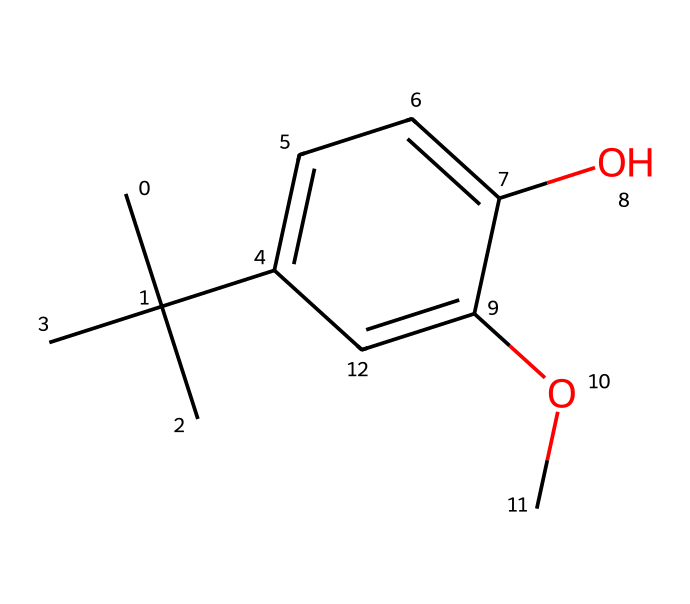What is the molecular formula of butylated hydroxyanisole? The SMILES representation can be analyzed to count the number of each type of atom present. In CC(C)(C), there are 4 carbons from the butyl group. The rest of the structure contains another 6 carbons from the aromatic ring. Including the attached functional groups, we see 10 carbons (C), 12 hydrogens (H), and 3 oxygens (O). Thus, the molecular formula is C10H14O3.
Answer: C10H14O3 How many carbon atoms are in butylated hydroxyanisole? By parsing the SMILES, we can identify that there are 10 carbon atoms in total, derived from the analysis of both the butyl group and the aromatic ring.
Answer: 10 What type of functional groups are present in butylated hydroxyanisole? The representations of -OH (hydroxyl group) and -OCH3 (methoxy group) can be identified in the structure. The presence of these groups categorizes it as a phenolic compound.
Answer: hydroxyl and methoxy Is butylated hydroxyanisole a polar or nonpolar molecule? Analyzing the structure, the presence of hydroxyl and methoxy groups contributes to polarity, while the hydrocarbon portions are nonpolar. The overall structure tends toward being more polar due to these functional groups.
Answer: polar What is the significance of the methoxy group in butylated hydroxyanisole? The methoxy group (OCH3) contributes to the antioxidant properties of BHA, aiding in radical scavenging because of the electron-donating attributes of the oxygen atom, enhancing its effectiveness as a preservative.
Answer: antioxidant properties Which part of butylated hydroxyanisole acts as a preservative? The hydroxyl group (-OH) and the aromatic ring are crucial for its ability to scavenge free radicals, which is vital for its function as an antioxidant and preservative in packaged foods.
Answer: hydroxyl group and aromatic ring 